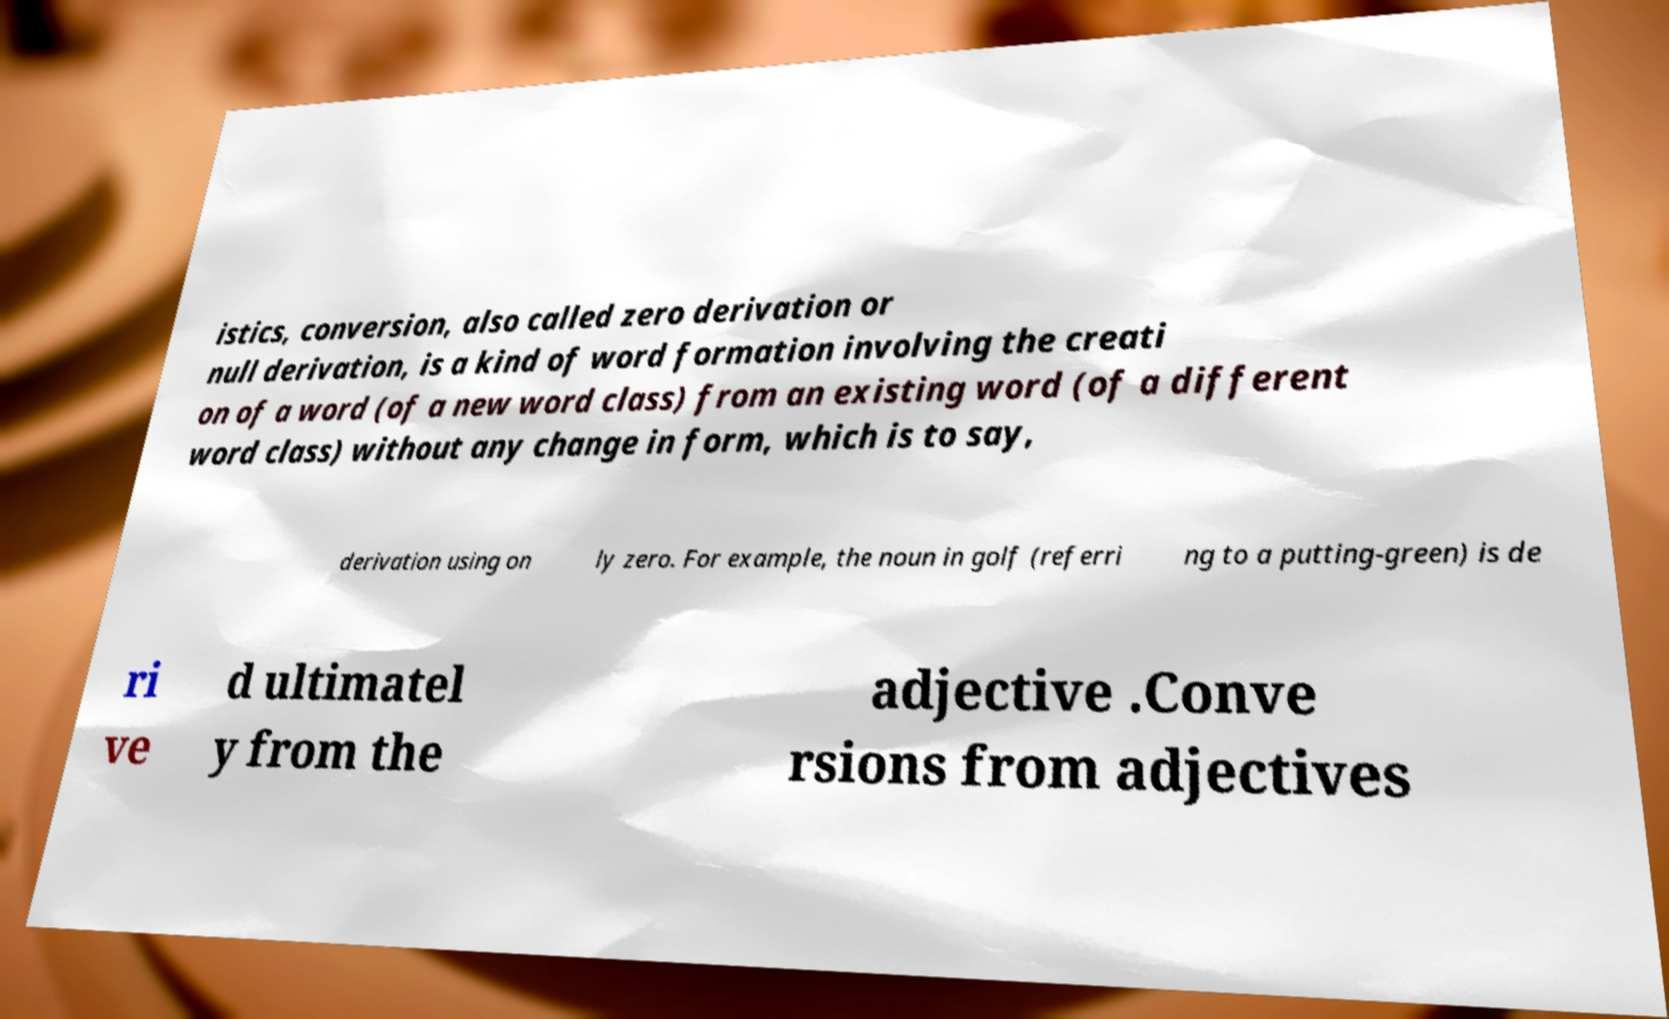Can you accurately transcribe the text from the provided image for me? istics, conversion, also called zero derivation or null derivation, is a kind of word formation involving the creati on of a word (of a new word class) from an existing word (of a different word class) without any change in form, which is to say, derivation using on ly zero. For example, the noun in golf (referri ng to a putting-green) is de ri ve d ultimatel y from the adjective .Conve rsions from adjectives 